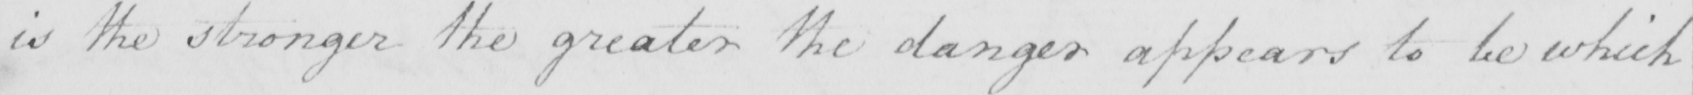Please provide the text content of this handwritten line. is the stronger the greater the danger appears to be which 